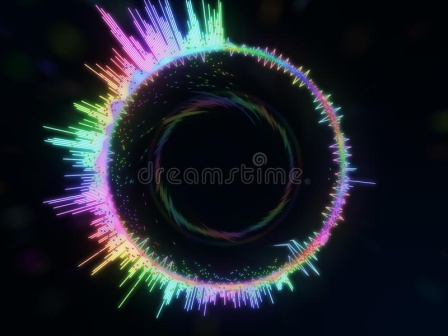Let's say this image is a visual representation of a piece of music. What might that music sound like? If this image were a visual representation of a piece of music, the composition would likely be a symphony of vibrant, overlapping melodies and harmonies. The music might start with a deep, resonant drone, representing the stark central black hole, gradually introducing shimmering, high-pitched notes that dance and swirl around it, mirroring the colorful aura. The piece could feature a rich tapestry of electronic and orchestral sounds, with pulsating rhythms and dynamic shifts in tempo and intensity, evoking the swirling motion and the interplay of colors. The overall effect would be mesmerizing and otherworldly, transporting listeners through the vast expanse of the cosmos, much like the visual journey offered by the image. Describe a realistic scenario that this image could represent in space. In a realistic scenario, this image could represent an artist's interpretation of a black hole surrounded by an accretion disk. The vibrant colors might symbolize the intense radiation emitted as matter is heated to extreme temperatures while spiraling into the black hole. This visualization highlights the chaotic, energetic processes occurring near the event horizon, where gravitational forces are incredibly strong. Such a depiction helps scientists and the public alike imagine the exotic and violent nature of these cosmic phenomena. Imagine this image is part of a futuristic virtual reality (VR) experience. What might that experience feel like? In a futuristic VR experience based on this image, users would feel as though they are floating in the vastness of space, surrounded by a cosmic spectacle. The experience could start with entering a dark, serene space, gradually approaching the vibrant, swirling black hole. Users would see and feel the intensity of the radiant lines, possibly experiencing gentle vibrations and sounds that sync with the dynamic colors and patterns. As they move closer, the swirling lines might seem to reach out and interact with them, creating an immersive experience of being enveloped by the cosmic energies. The VR experience would evoke a sense of awe, wonder, and perhaps even a touch of the unknown, allowing users to feel like explorers of the deepest, most enigmatic regions of the universe. 